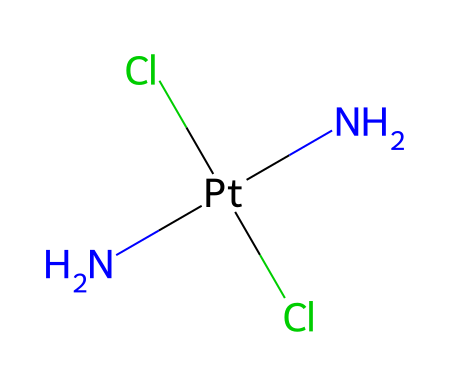What is the central metal atom in this compound? The compound has a platinum atom at its center, as indicated by the 'Pt' in the SMILES notation. It serves as the central metal in the coordination complex.
Answer: platinum How many chloride ions are there in the structure? The SMILES representation shows two 'Cl' atoms, indicating that there are two chloride ions in the structure of cisplatin.
Answer: two What type of coordination geometry does this compound exhibit? Given the presence of a central metal atom (platinum) bonded to two chloride ions and two amine groups, the geometry is square planar, typical for coordination compounds with a coordination number of four.
Answer: square planar How many nitrogen atoms are present in the structure? The SMILES notation includes 'N' twice, signifying that there are two nitrogen atoms attached to the platinum central atom.
Answer: two What is the primary therapeutic use of cisplatin? Cisplatin is primarily used in chemotherapy for treating various types of cancer, making it an important medical compound in oncology.
Answer: chemotherapy Why is cisplatin classified as a coordination compound? Cisplatin is classified as a coordination compound because it features a central metal atom surrounded by ligands (chloride ions and amine groups) that coordinate to it, forming a complex.
Answer: coordination compound 